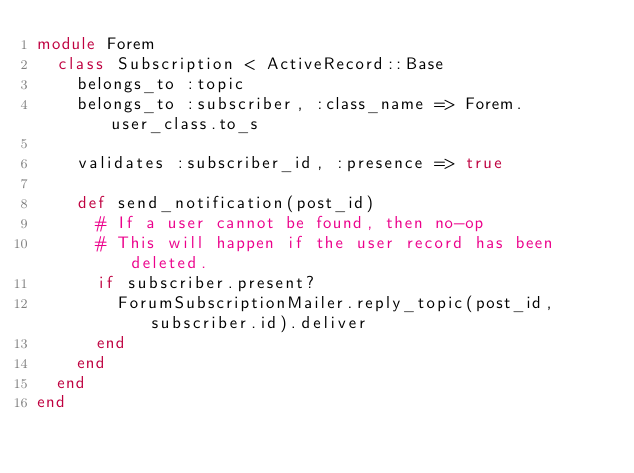Convert code to text. <code><loc_0><loc_0><loc_500><loc_500><_Ruby_>module Forem
  class Subscription < ActiveRecord::Base
    belongs_to :topic
    belongs_to :subscriber, :class_name => Forem.user_class.to_s

    validates :subscriber_id, :presence => true

    def send_notification(post_id)
      # If a user cannot be found, then no-op
      # This will happen if the user record has been deleted.
      if subscriber.present?
        ForumSubscriptionMailer.reply_topic(post_id, subscriber.id).deliver
      end
    end
  end
end
</code> 